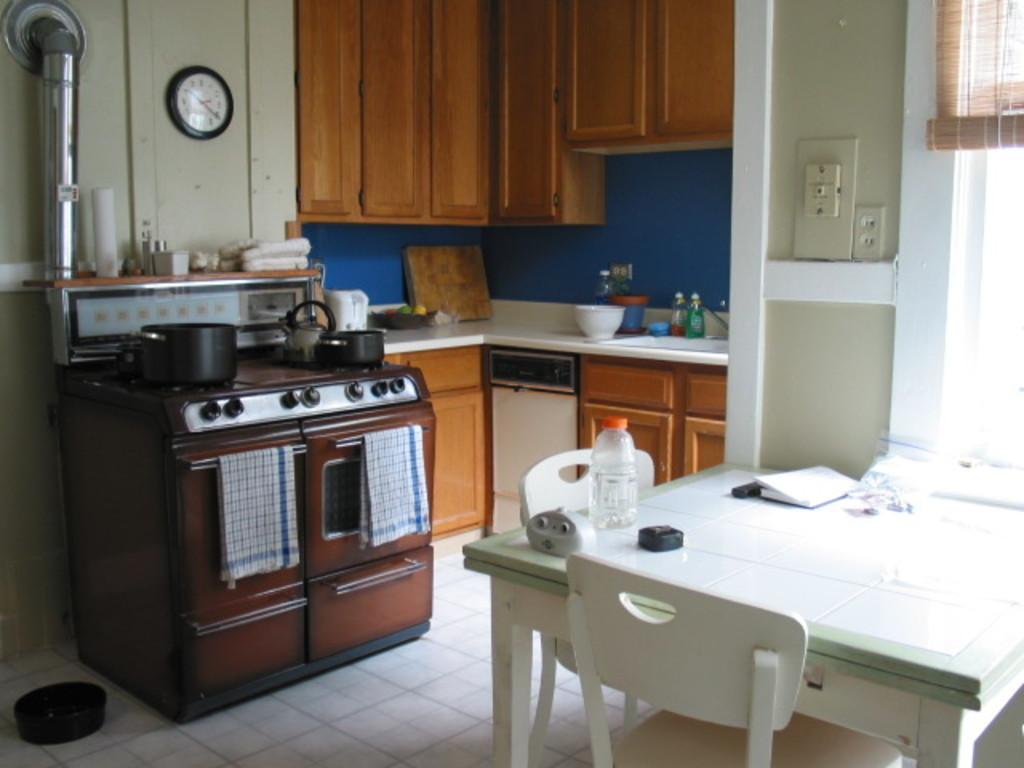In one or two sentences, can you explain what this image depicts? In this image in the center there is a table which is white in colour. On the table there is a bottle and there are papers and there is an object which is black in colour. There are two empty chairs. In the center there is a stove and on the stove there are utensils and in front of the stove there are clothes hanging and there is a platform, on the platform there are objects which are white and blue in colour and there are bottles. On the wall there are wardrobes and there is a clock hanging. On the right side there is a window and there is a window curtain. On the left side there is an object which is black in colour on the floor. 